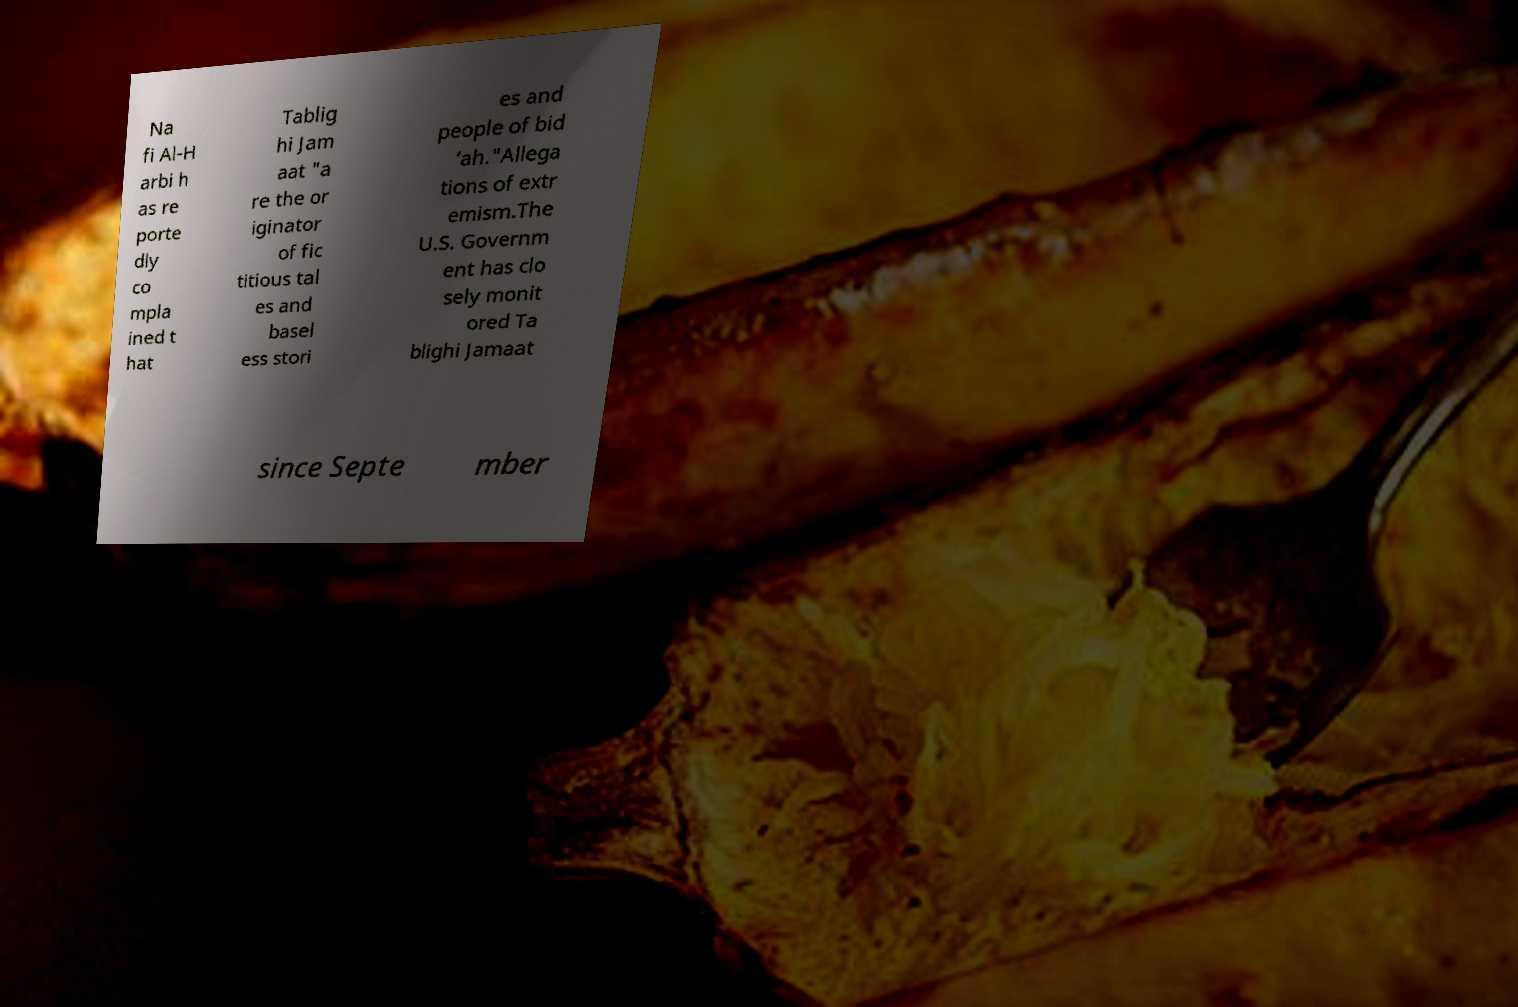Could you extract and type out the text from this image? Na fi Al-H arbi h as re porte dly co mpla ined t hat Tablig hi Jam aat "a re the or iginator of fic titious tal es and basel ess stori es and people of bid ‘ah."Allega tions of extr emism.The U.S. Governm ent has clo sely monit ored Ta blighi Jamaat since Septe mber 